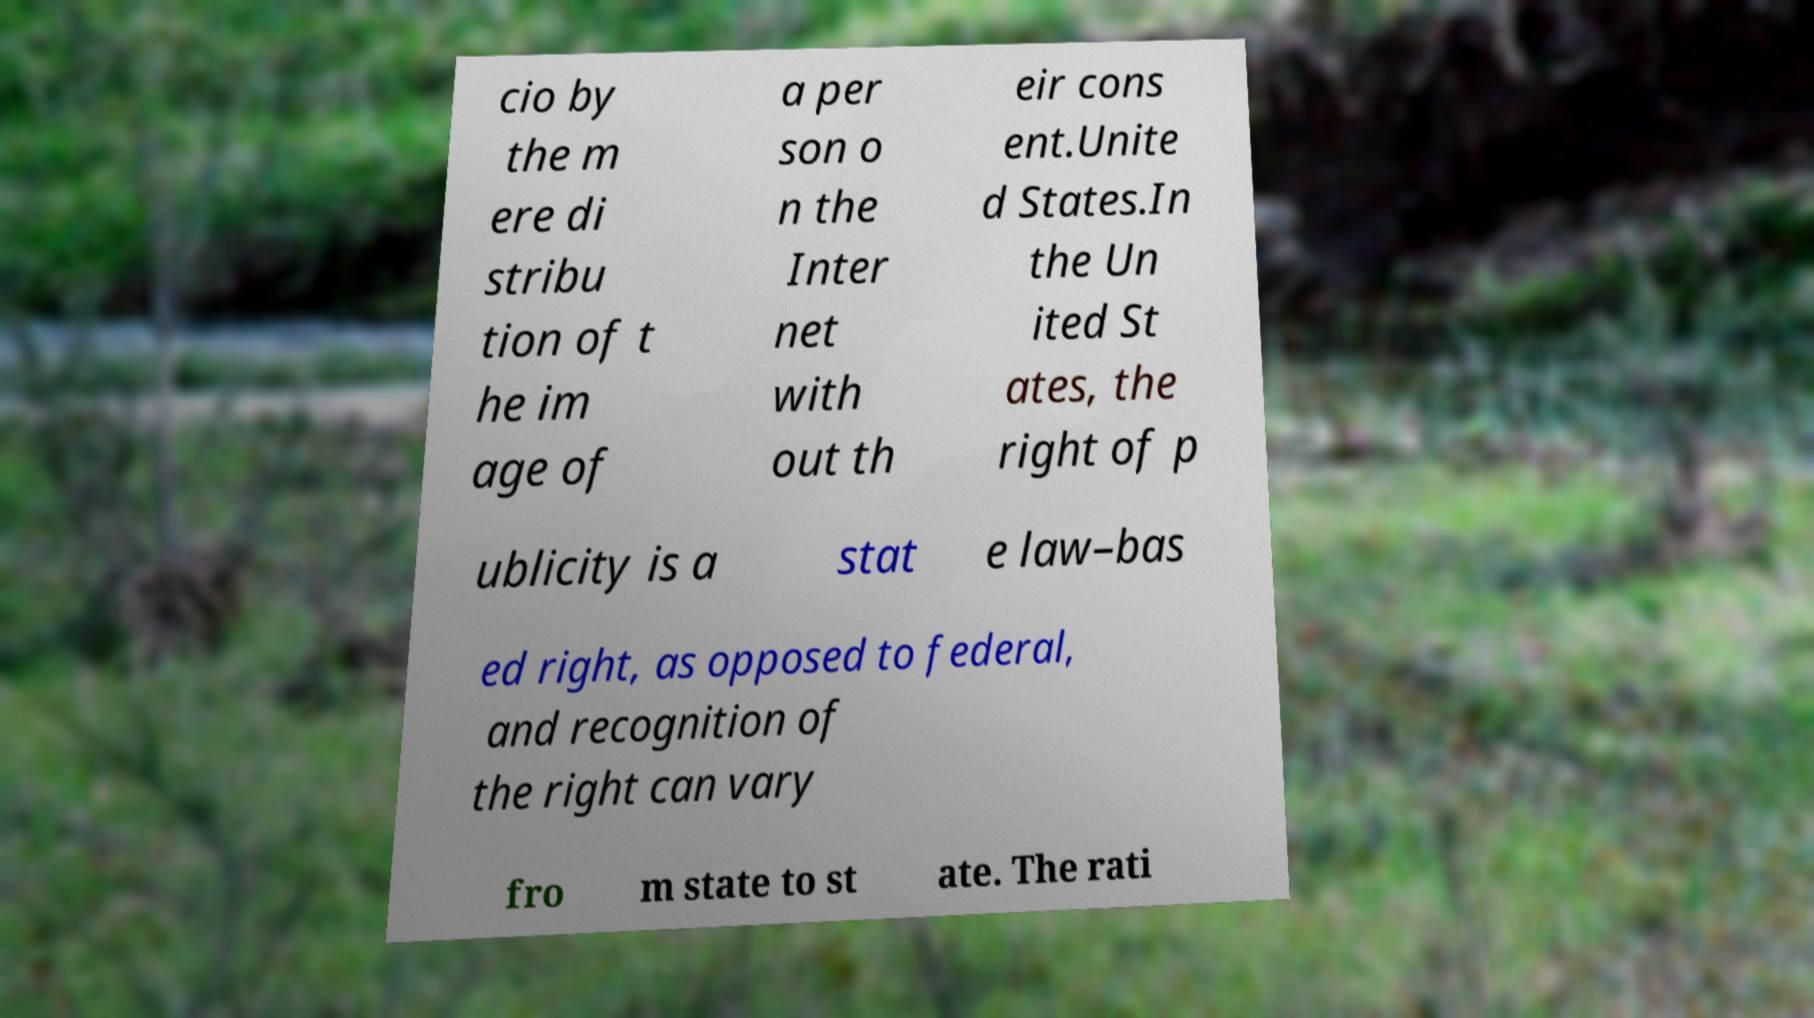For documentation purposes, I need the text within this image transcribed. Could you provide that? cio by the m ere di stribu tion of t he im age of a per son o n the Inter net with out th eir cons ent.Unite d States.In the Un ited St ates, the right of p ublicity is a stat e law–bas ed right, as opposed to federal, and recognition of the right can vary fro m state to st ate. The rati 